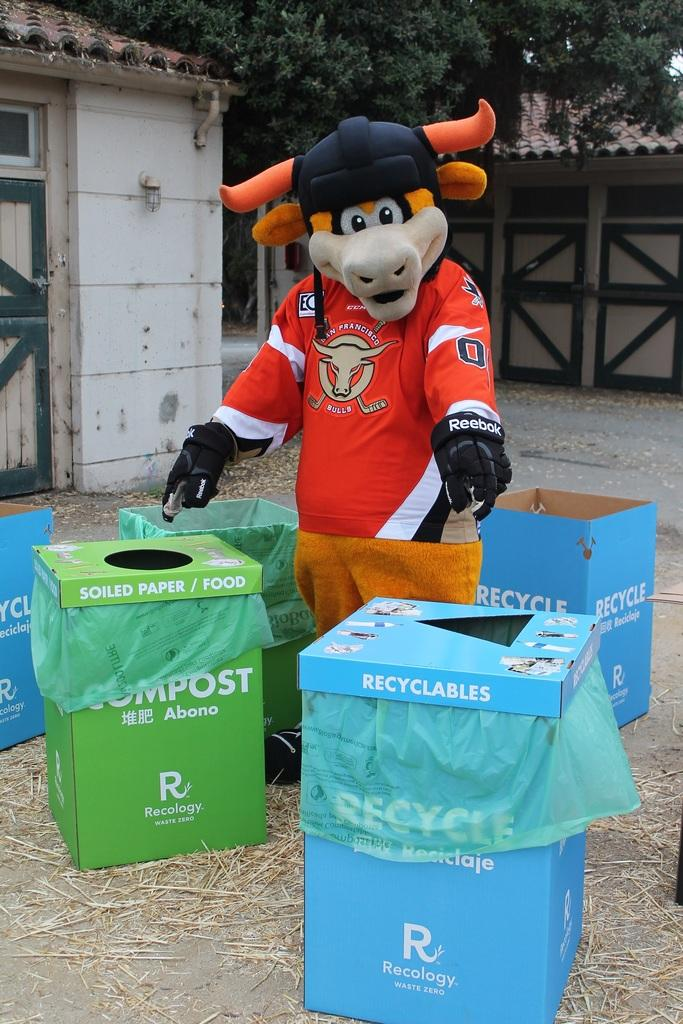<image>
Render a clear and concise summary of the photo. Mascot standing next to a blue box which says RECYCLABLES. 